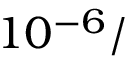<formula> <loc_0><loc_0><loc_500><loc_500>1 0 ^ { - 6 } /</formula> 